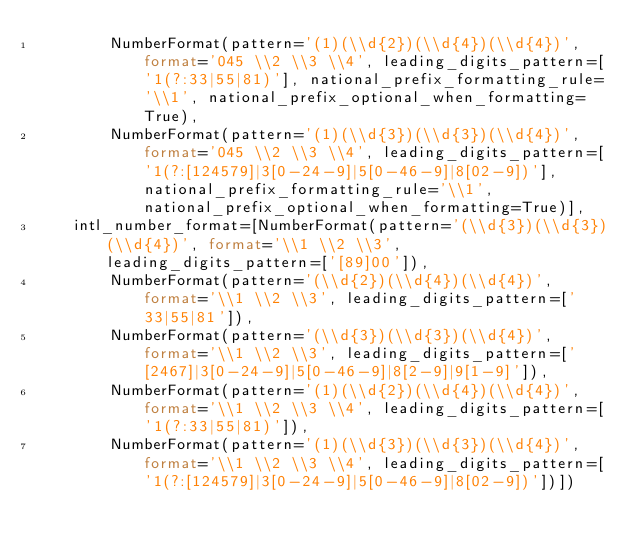<code> <loc_0><loc_0><loc_500><loc_500><_Python_>        NumberFormat(pattern='(1)(\\d{2})(\\d{4})(\\d{4})', format='045 \\2 \\3 \\4', leading_digits_pattern=['1(?:33|55|81)'], national_prefix_formatting_rule='\\1', national_prefix_optional_when_formatting=True),
        NumberFormat(pattern='(1)(\\d{3})(\\d{3})(\\d{4})', format='045 \\2 \\3 \\4', leading_digits_pattern=['1(?:[124579]|3[0-24-9]|5[0-46-9]|8[02-9])'], national_prefix_formatting_rule='\\1', national_prefix_optional_when_formatting=True)],
    intl_number_format=[NumberFormat(pattern='(\\d{3})(\\d{3})(\\d{4})', format='\\1 \\2 \\3', leading_digits_pattern=['[89]00']),
        NumberFormat(pattern='(\\d{2})(\\d{4})(\\d{4})', format='\\1 \\2 \\3', leading_digits_pattern=['33|55|81']),
        NumberFormat(pattern='(\\d{3})(\\d{3})(\\d{4})', format='\\1 \\2 \\3', leading_digits_pattern=['[2467]|3[0-24-9]|5[0-46-9]|8[2-9]|9[1-9]']),
        NumberFormat(pattern='(1)(\\d{2})(\\d{4})(\\d{4})', format='\\1 \\2 \\3 \\4', leading_digits_pattern=['1(?:33|55|81)']),
        NumberFormat(pattern='(1)(\\d{3})(\\d{3})(\\d{4})', format='\\1 \\2 \\3 \\4', leading_digits_pattern=['1(?:[124579]|3[0-24-9]|5[0-46-9]|8[02-9])'])])
</code> 